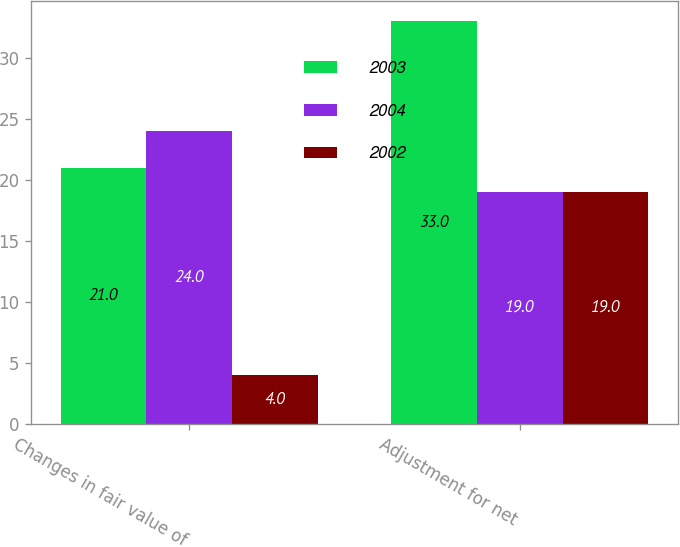Convert chart to OTSL. <chart><loc_0><loc_0><loc_500><loc_500><stacked_bar_chart><ecel><fcel>Changes in fair value of<fcel>Adjustment for net<nl><fcel>2003<fcel>21<fcel>33<nl><fcel>2004<fcel>24<fcel>19<nl><fcel>2002<fcel>4<fcel>19<nl></chart> 